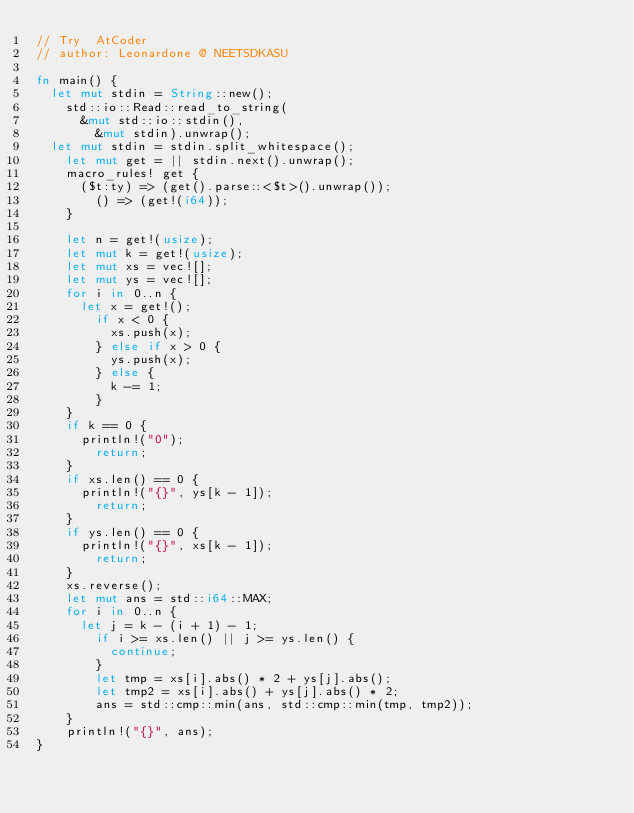Convert code to text. <code><loc_0><loc_0><loc_500><loc_500><_Rust_>// Try  AtCoder
// author: Leonardone @ NEETSDKASU

fn main() {
	let mut stdin = String::new();
    std::io::Read::read_to_string(
    	&mut std::io::stdin(),
        &mut stdin).unwrap();
	let mut stdin = stdin.split_whitespace();
    let mut get = || stdin.next().unwrap();
    macro_rules! get {
    	($t:ty) => (get().parse::<$t>().unwrap());
        () => (get!(i64));
    }
    
    let n = get!(usize);
    let mut k = get!(usize);
    let mut xs = vec![];
    let mut ys = vec![];
    for i in 0..n {
    	let x = get!();
        if x < 0 {
	        xs.push(x);
        } else if x > 0 {
        	ys.push(x);
        } else {
        	k -= 1;
        }
    }
    if k == 0 {
    	println!("0");
        return;
    }
    if xs.len() == 0 {
    	println!("{}", ys[k - 1]);
        return;
    }
    if ys.len() == 0 {
    	println!("{}", xs[k - 1]);
        return;
    }
    xs.reverse();
    let mut ans = std::i64::MAX;
    for i in 0..n {
    	let j = k - (i + 1) - 1;
        if i >= xs.len() || j >= ys.len() {
        	continue;
        }
        let tmp = xs[i].abs() * 2 + ys[j].abs();
        let tmp2 = xs[i].abs() + ys[j].abs() * 2;
        ans = std::cmp::min(ans, std::cmp::min(tmp, tmp2));
    }
    println!("{}", ans);
}</code> 